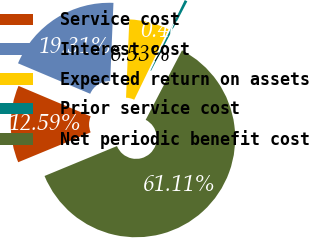<chart> <loc_0><loc_0><loc_500><loc_500><pie_chart><fcel>Service cost<fcel>Interest cost<fcel>Expected return on assets<fcel>Prior service cost<fcel>Net periodic benefit cost<nl><fcel>12.59%<fcel>19.31%<fcel>6.53%<fcel>0.46%<fcel>61.1%<nl></chart> 